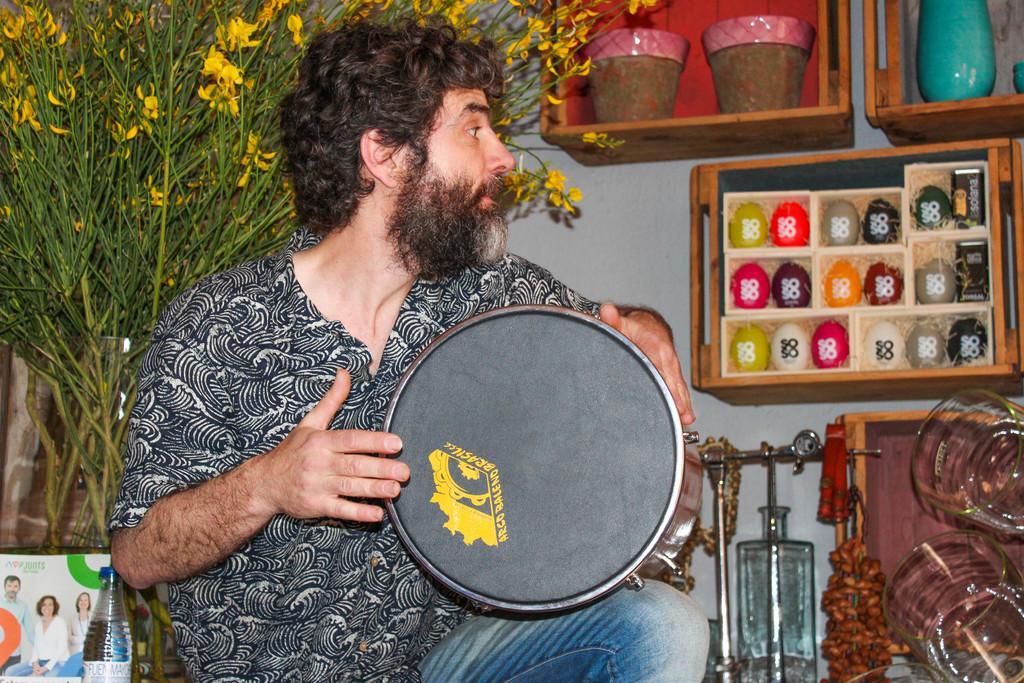Can you describe this image briefly? In this image I can see a person holding the drum. In the back there is a plant and the flowertots. 